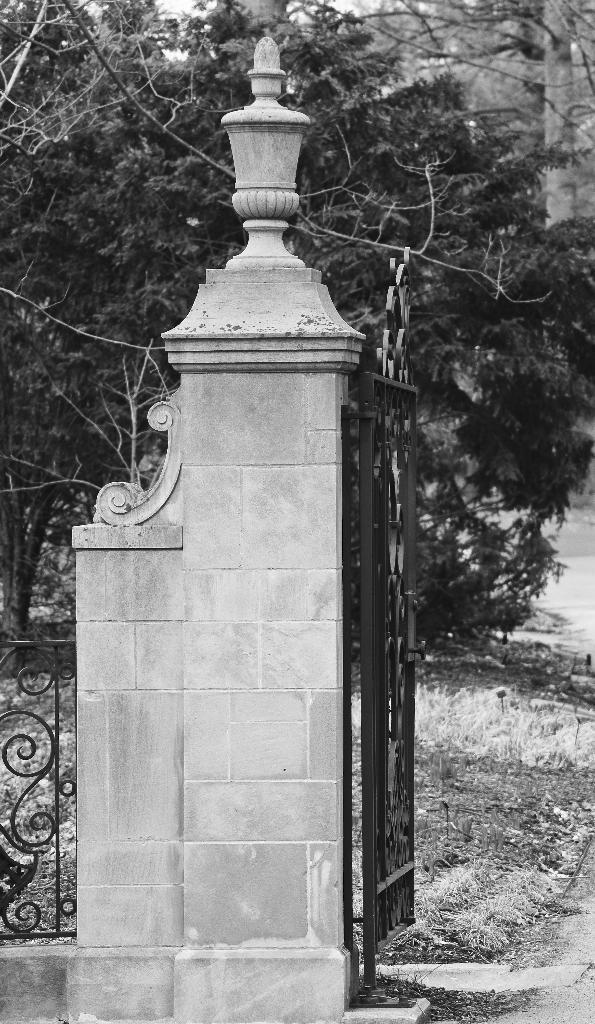How would you summarize this image in a sentence or two? This picture shows a metal gate and we see a metal fence and few trees and grass on the ground 